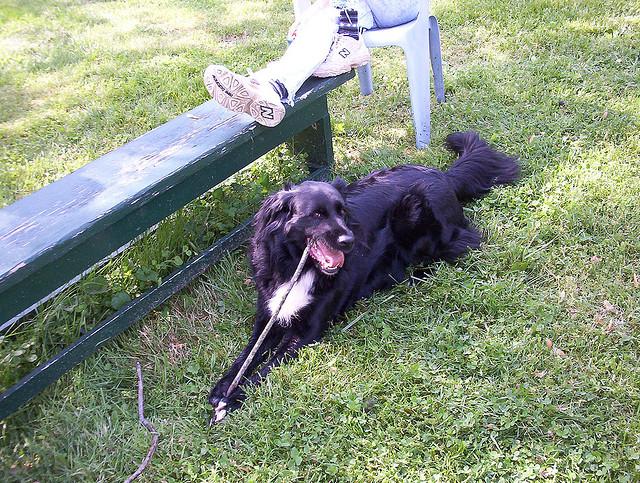What does the dog have in his mouth?
Quick response, please. Stick. Is the dog happy?
Answer briefly. Yes. Is there a human in the image?
Quick response, please. Yes. 